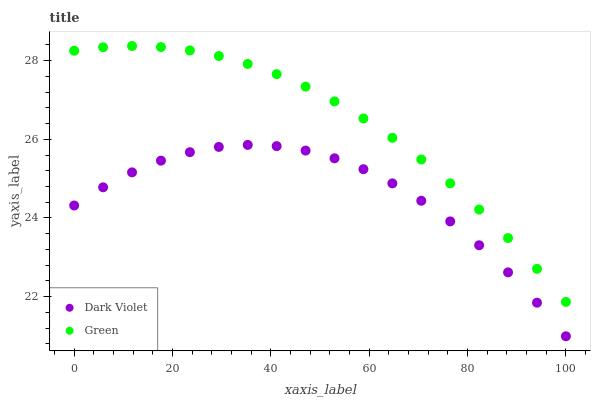Does Dark Violet have the minimum area under the curve?
Answer yes or no. Yes. Does Green have the maximum area under the curve?
Answer yes or no. Yes. Does Dark Violet have the maximum area under the curve?
Answer yes or no. No. Is Green the smoothest?
Answer yes or no. Yes. Is Dark Violet the roughest?
Answer yes or no. Yes. Is Dark Violet the smoothest?
Answer yes or no. No. Does Dark Violet have the lowest value?
Answer yes or no. Yes. Does Green have the highest value?
Answer yes or no. Yes. Does Dark Violet have the highest value?
Answer yes or no. No. Is Dark Violet less than Green?
Answer yes or no. Yes. Is Green greater than Dark Violet?
Answer yes or no. Yes. Does Dark Violet intersect Green?
Answer yes or no. No. 